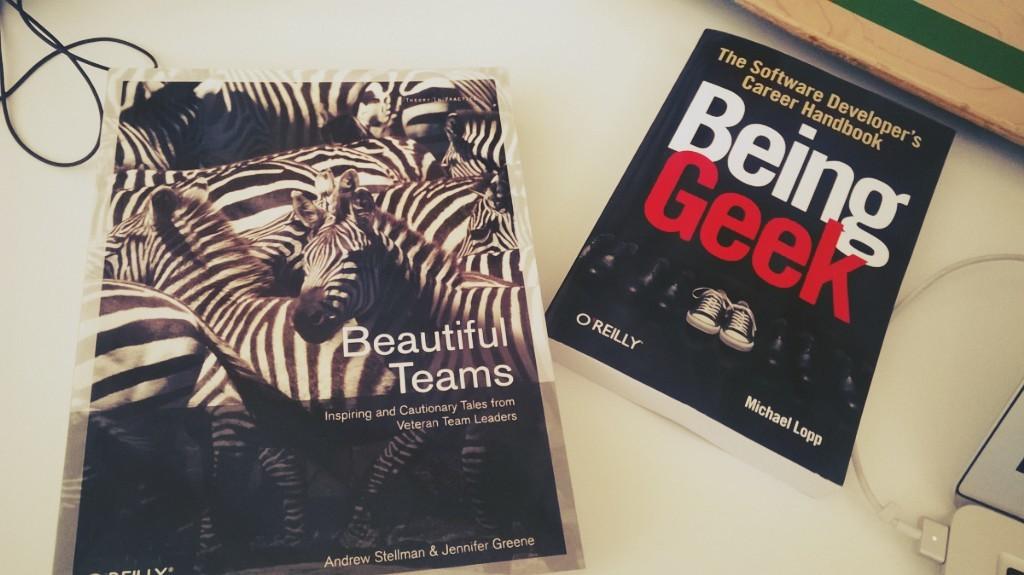What animal is on the book?
Provide a succinct answer. Answering does not require reading text in the image. What is the book beautiful teams about?
Keep it short and to the point. Inspiring and cautionary tales. 